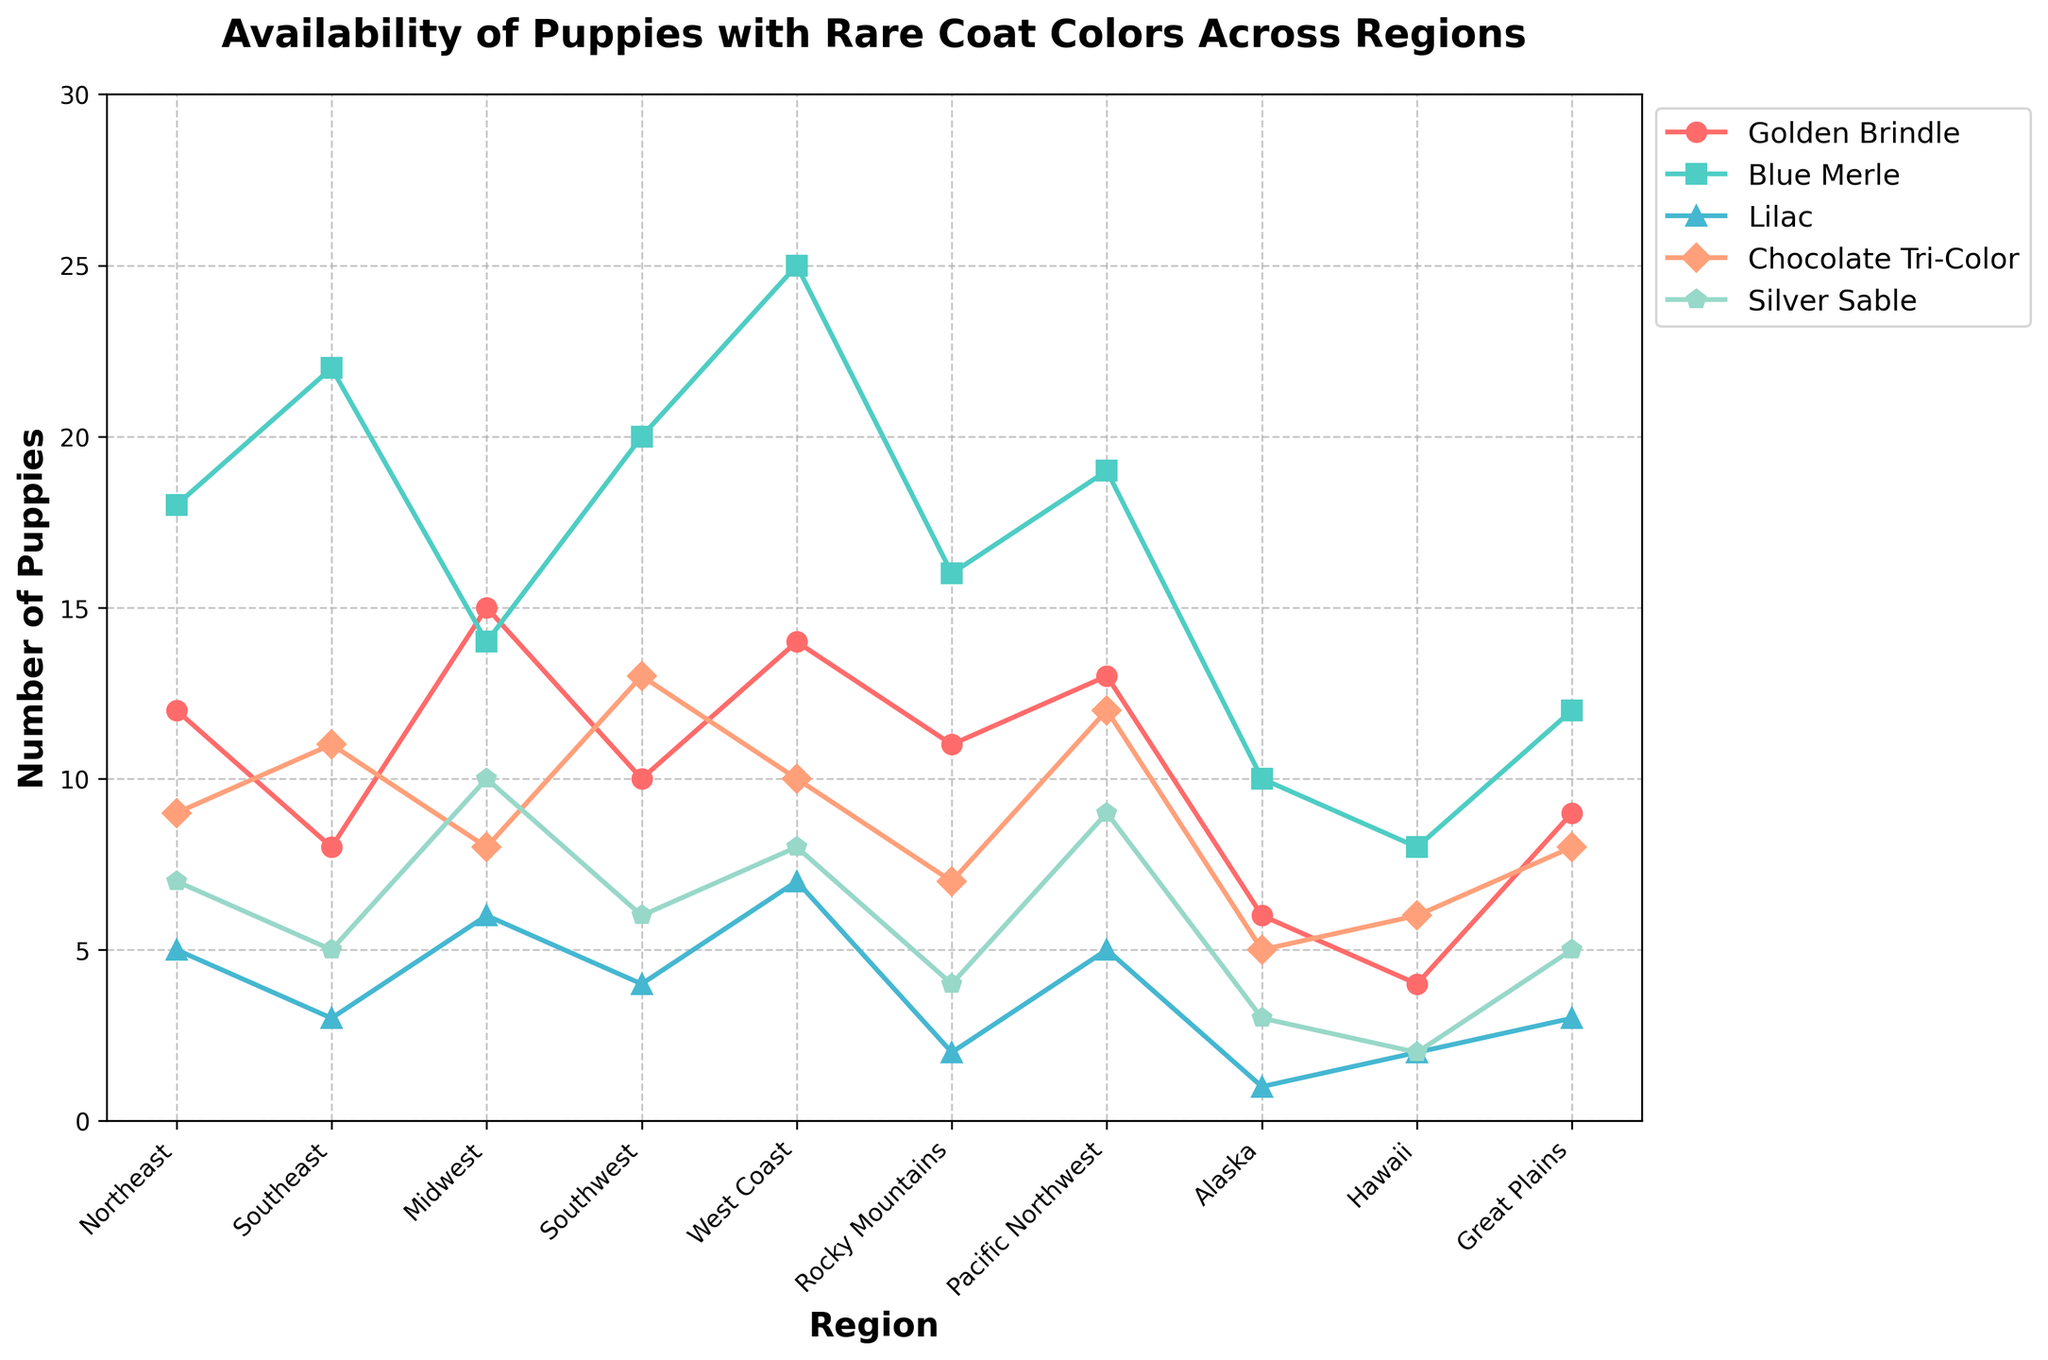Which region has the highest number of Blue Merle puppies? The line representing Blue Merle puppies peaks at the West Coast, making it the region with the highest number of Blue Merle puppies.
Answer: West Coast How many more Chocolate Tri-Color puppies are available in the Southwest compared to the Northeast? The figure shows 13 Chocolate Tri-Color puppies in the Southwest and 9 in the Northeast, so the difference is 13 - 9 = 4.
Answer: 4 Which region has the fewest Golden Brindle puppies? The line for Golden Brindle puppies is lowest at Hawaii, indicating it has the fewest Golden Brindle puppies.
Answer: Hawaii What is the average number of Silver Sable puppies available across all the regions? Adding up the Silver Sable puppies: 7 + 5 + 10 + 6 + 8 + 4 + 9 + 3 + 2 + 5 = 59. There are 10 regions, so the average is 59 / 10 = 5.9.
Answer: 5.9 Is the number of Lilac puppies in the Midwest greater than or equal to the number of Chocolate Tri-Color puppies in Alaska? The figure shows 6 Lilac puppies in the Midwest and 5 Chocolate Tri-Color puppies in Alaska. Since 6 >= 5 is true, the statement holds.
Answer: Yes In which region is the difference between the numbers of Blue Merle and Golden Brindle puppies the greatest? Calculate differences: West Coast (25-14=11), Southeast (22-8=14), Pacific Northwest (19-13=6), etc. The Southeast, with a difference of 14, has the greatest difference.
Answer: Southeast Which breed has the most consistent number of puppies across all regions, i.e., the least variation? Visual evaluation shows that Golden Brindle has the least fluctuation in the number of puppies across all regions.
Answer: Golden Brindle What is the total number of Lilac puppies available in the West Coast and Pacific Northwest combined? Add the number of Lilac puppies in both regions: 7 (West Coast) + 5 (Pacific Northwest) = 12.
Answer: 12 